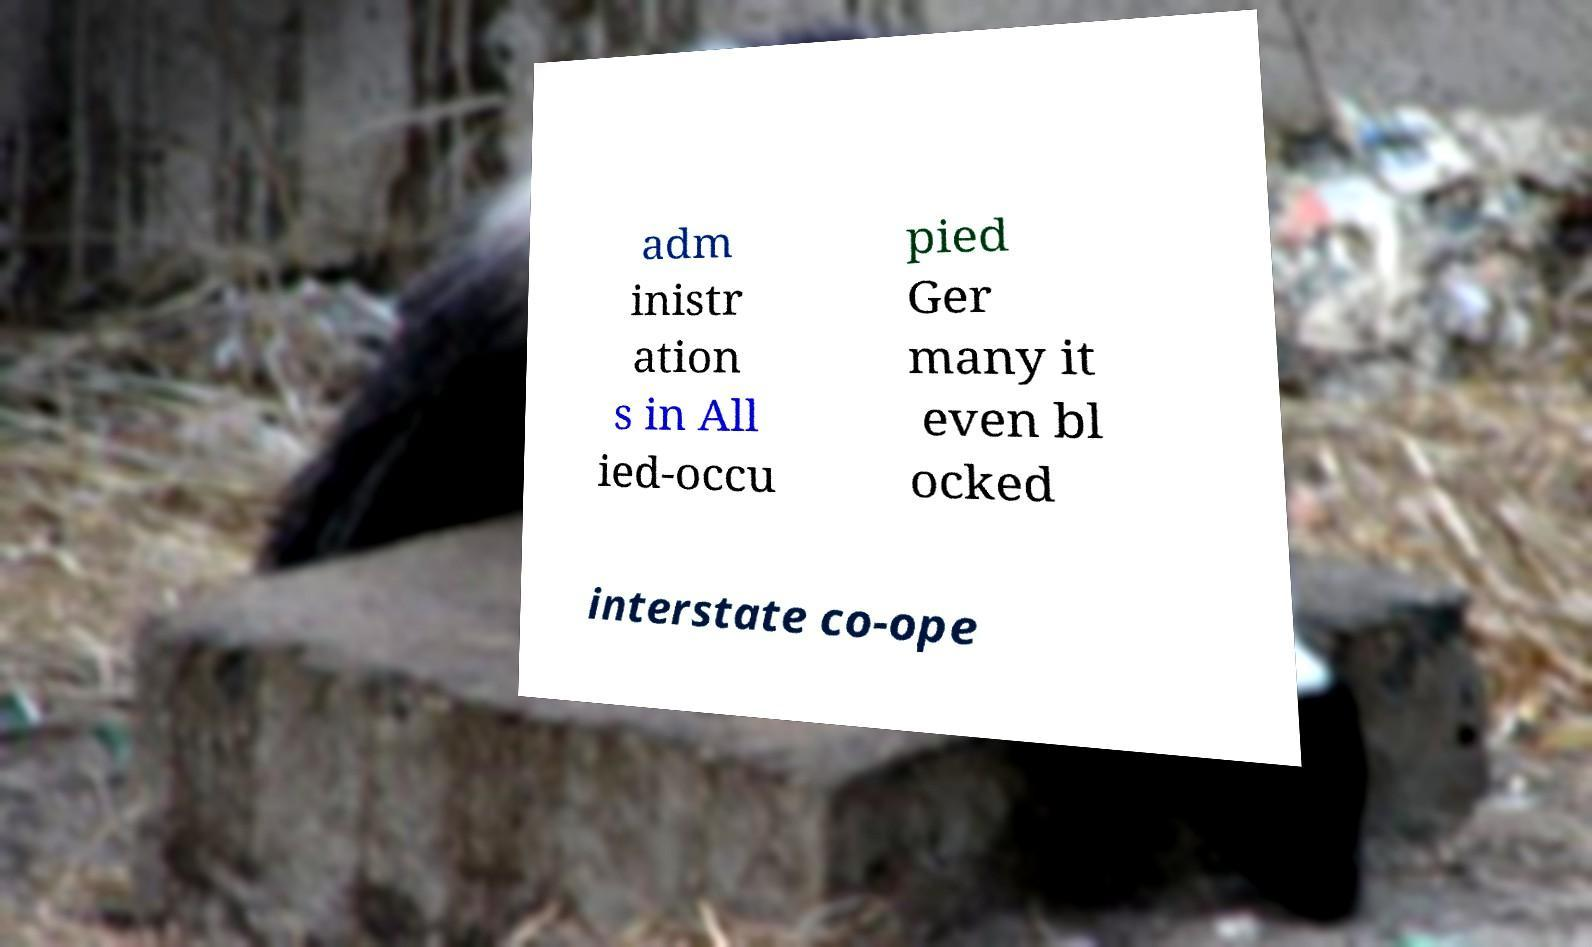There's text embedded in this image that I need extracted. Can you transcribe it verbatim? adm inistr ation s in All ied-occu pied Ger many it even bl ocked interstate co-ope 